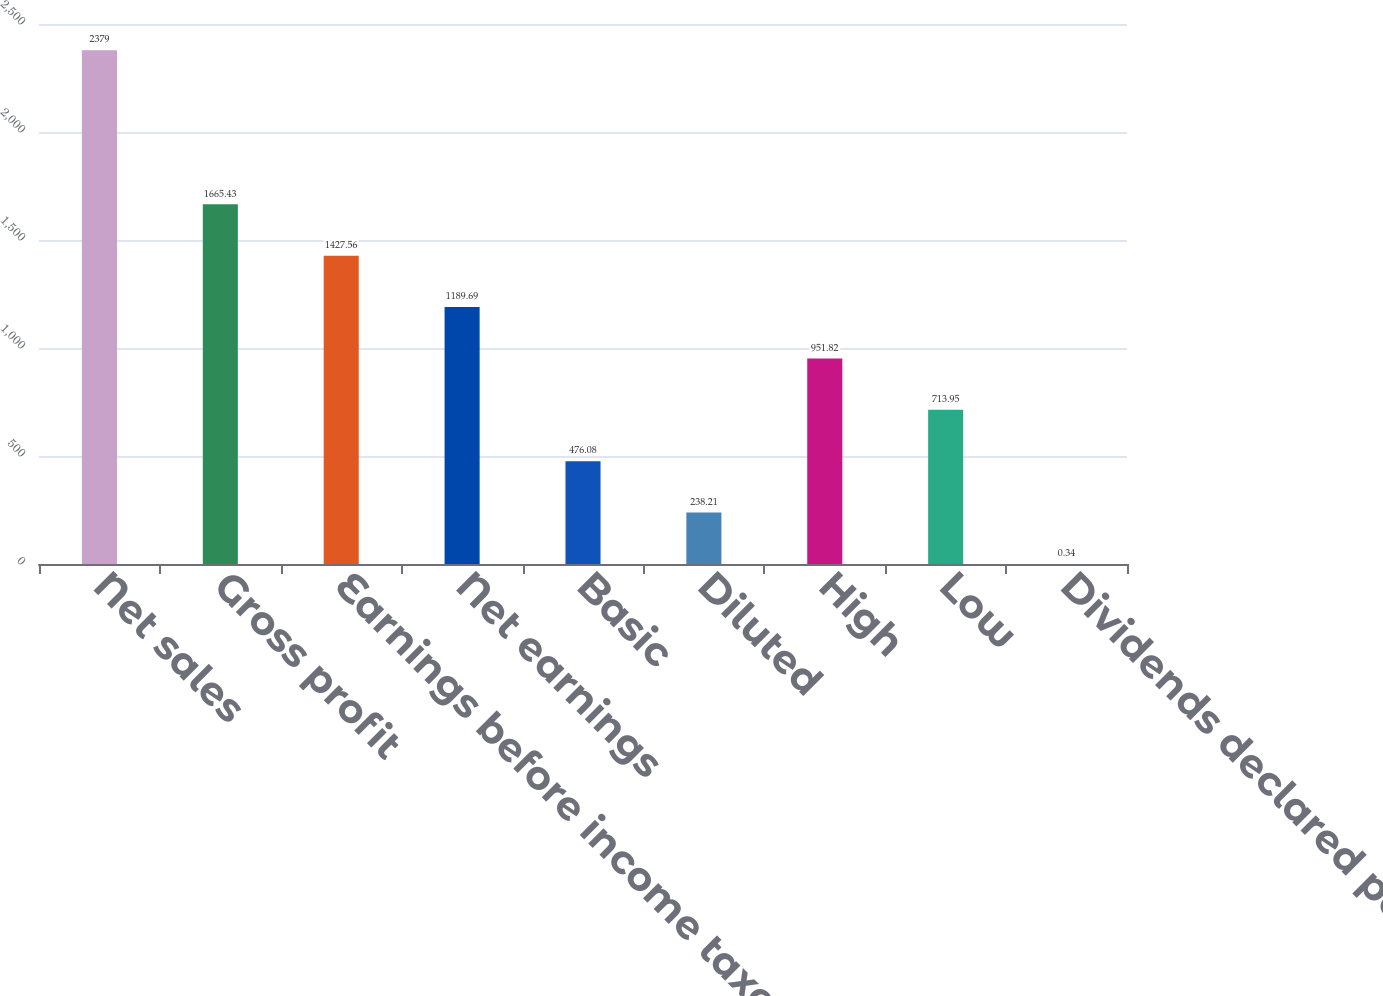Convert chart to OTSL. <chart><loc_0><loc_0><loc_500><loc_500><bar_chart><fcel>Net sales<fcel>Gross profit<fcel>Earnings before income taxes<fcel>Net earnings<fcel>Basic<fcel>Diluted<fcel>High<fcel>Low<fcel>Dividends declared per share<nl><fcel>2379<fcel>1665.43<fcel>1427.56<fcel>1189.69<fcel>476.08<fcel>238.21<fcel>951.82<fcel>713.95<fcel>0.34<nl></chart> 